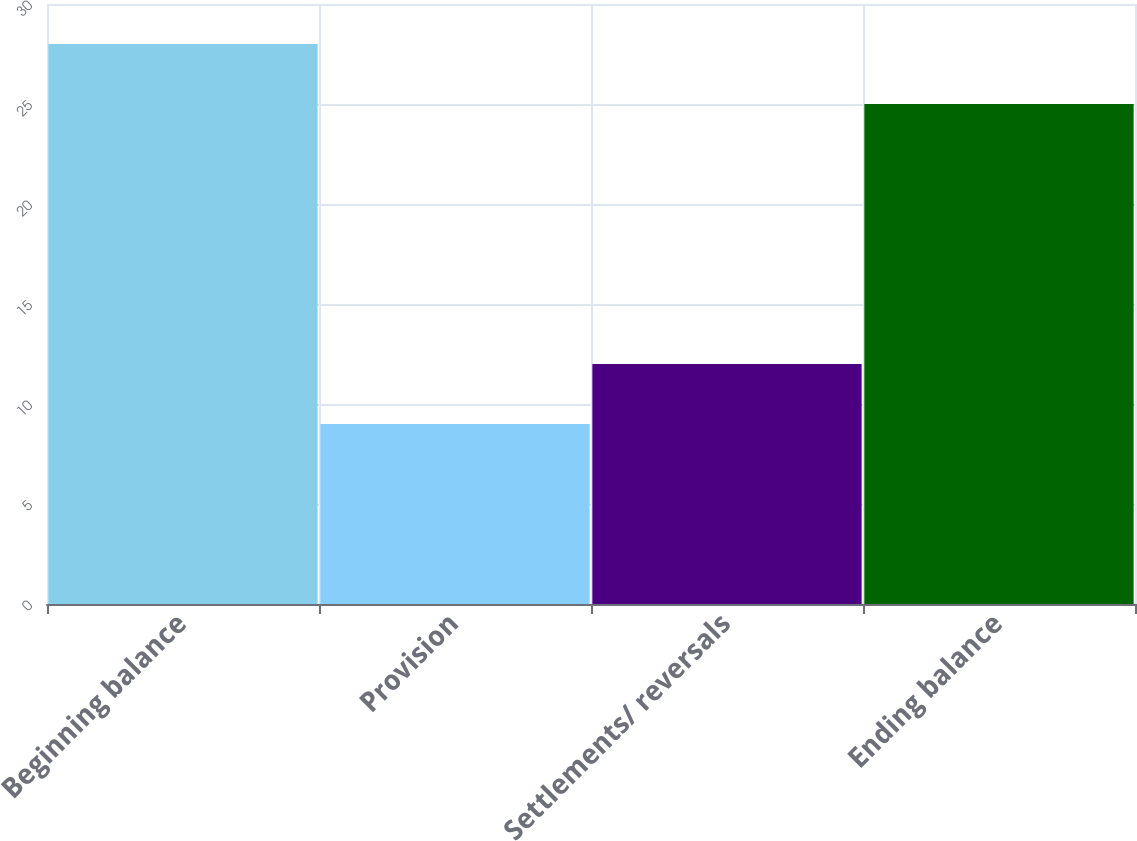Convert chart to OTSL. <chart><loc_0><loc_0><loc_500><loc_500><bar_chart><fcel>Beginning balance<fcel>Provision<fcel>Settlements/ reversals<fcel>Ending balance<nl><fcel>28<fcel>9<fcel>12<fcel>25<nl></chart> 